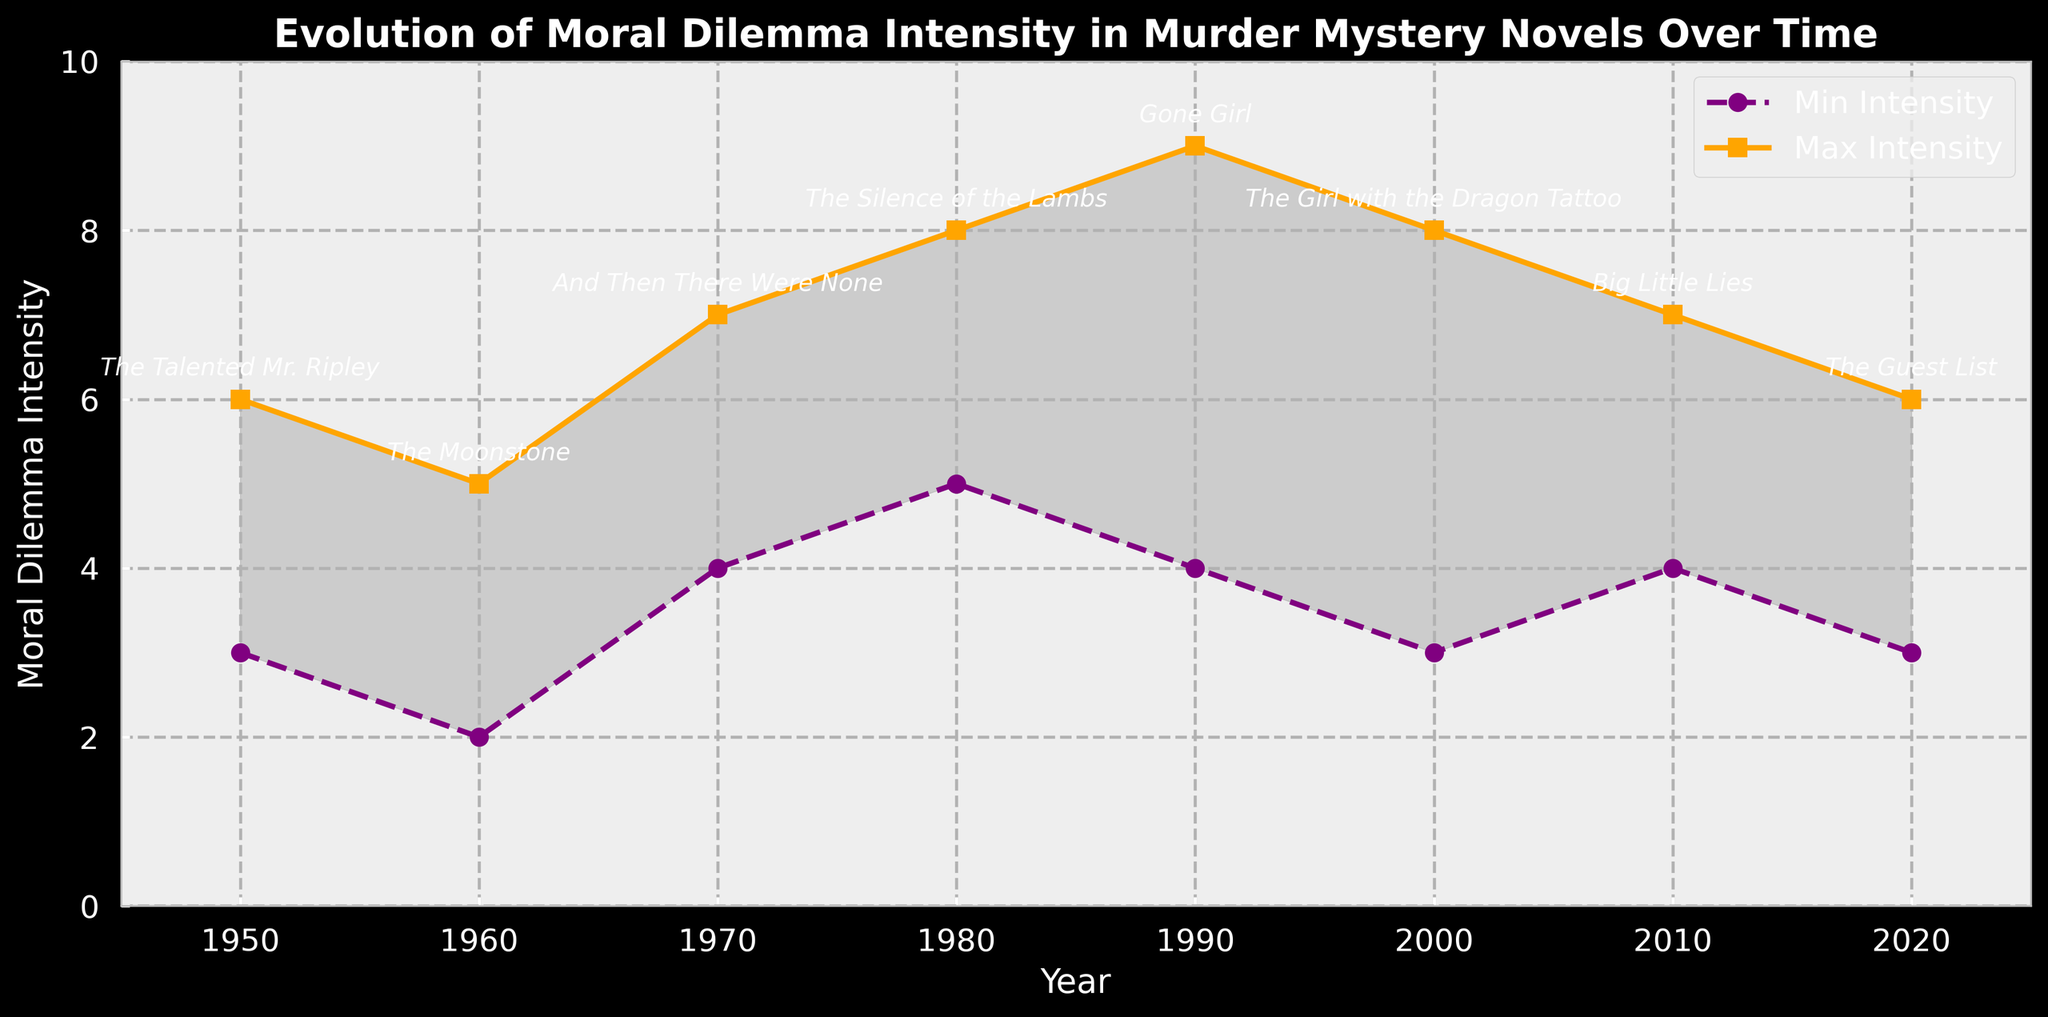What's the range of moral dilemma intensity in "Gone Girl"? The minimum intensity for "Gone Girl" is 4, and the maximum is 9. The range is calculated as the difference between the maximum and minimum values, which is 9 - 4 = 5.
Answer: 5 Which novel has the highest maximum moral dilemma intensity? The novel with the highest maximum intensity is "Gone Girl," which has a maximum moral dilemma intensity of 9, as indicated by the highest point on the orange line.
Answer: Gone Girl How did the range of moral dilemma intensity change from "And Then There Were None" to "The Guest List"? "And Then There Were None" has a minimum intensity of 4 and a maximum of 7 (range = 3). "The Guest List" has a minimum intensity of 3 and a maximum of 6 (range = 3). The range did not change; it remained the same at 3.
Answer: No change Compare the minimum moral dilemma intensity of "The Silence of the Lambs" to "Big Little Lies". Which one is higher? "The Silence of the Lambs" has a minimum intensity of 5, and "Big Little Lies" has a minimum intensity of 4. Therefore, "The Silence of the Lambs" has the higher minimum intensity.
Answer: The Silence of the Lambs Which period saw the steepest increase in maximum moral dilemma intensity? The steepest increase in maximum intensity is noticed between 1980 ("The Silence of the Lambs" with a maximum intensity of 8) and 1990 ("Gone Girl" with a maximum intensity of 9). The increase is 1 unit over a 10-year period.
Answer: 1980 to 1990 What is the average maximum moral dilemma intensity for the novels listed? The maximum intensities are 6, 5, 7, 8, 9, 8, 7, and 6. Summing these gives a total of 56. There are 8 novels, so the average is 56/8 = 7.
Answer: 7 Which novel has the widest gap between minimum and maximum moral dilemma intensity, and what is the gap? "Gone Girl" has the widest gap, with a minimum intensity of 4 and a maximum of 9. The gap is 9 - 4 = 5.
Answer: Gone Girl, 5 What colors represent the lines showing minimum and maximum moral dilemma intensity? The line for minimum intensity is purple, and the line for maximum intensity is orange. This is based on the visual attributes shown in the figure.
Answer: Purple and Orange How does the minimum moral dilemma intensity trend change from 1950 to 2020? The minimum intensity starts at 3 in 1950, slightly lowers to 2 in 1960, increases and oscillates until 1980 where it is 5, dips to 3 in 2000, and stabilizes at 4-3 from 2010 to 2020. The overall trend is upward with some fluctuations.
Answer: Upward with fluctuations Compare the range of moral dilemma intensity in the novel "The Talented Mr. Ripley" to "The Girl with the Dragon Tattoo". Which one is more consistent in terms of moral dilemma intensity? "The Talented Mr. Ripley" has a range of 6 - 3 = 3. "The Girl with the Dragon Tattoo" has a range of 8 - 3 = 5. "The Talented Mr. Ripley" is more consistent with a smaller range.
Answer: The Talented Mr. Ripley 